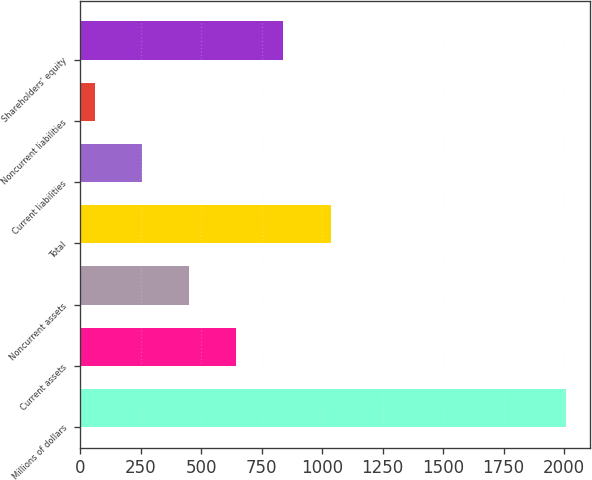Convert chart. <chart><loc_0><loc_0><loc_500><loc_500><bar_chart><fcel>Millions of dollars<fcel>Current assets<fcel>Noncurrent assets<fcel>Total<fcel>Current liabilities<fcel>Noncurrent liabilities<fcel>Shareholders' equity<nl><fcel>2007<fcel>645.5<fcel>451<fcel>1034.5<fcel>256.5<fcel>62<fcel>840<nl></chart> 